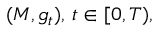Convert formula to latex. <formula><loc_0><loc_0><loc_500><loc_500>( M , g _ { t } ) , \, t \in [ 0 , T ) ,</formula> 